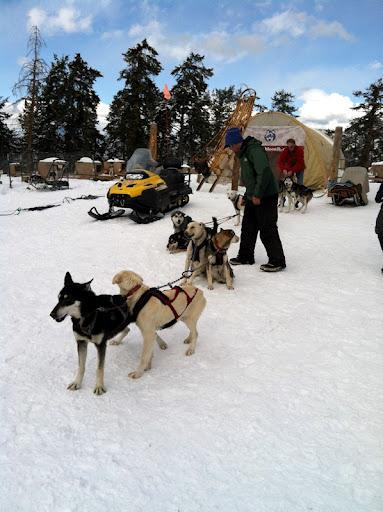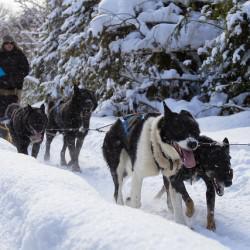The first image is the image on the left, the second image is the image on the right. Considering the images on both sides, is "sled dogs are wearing protective foot coverings" valid? Answer yes or no. No. 